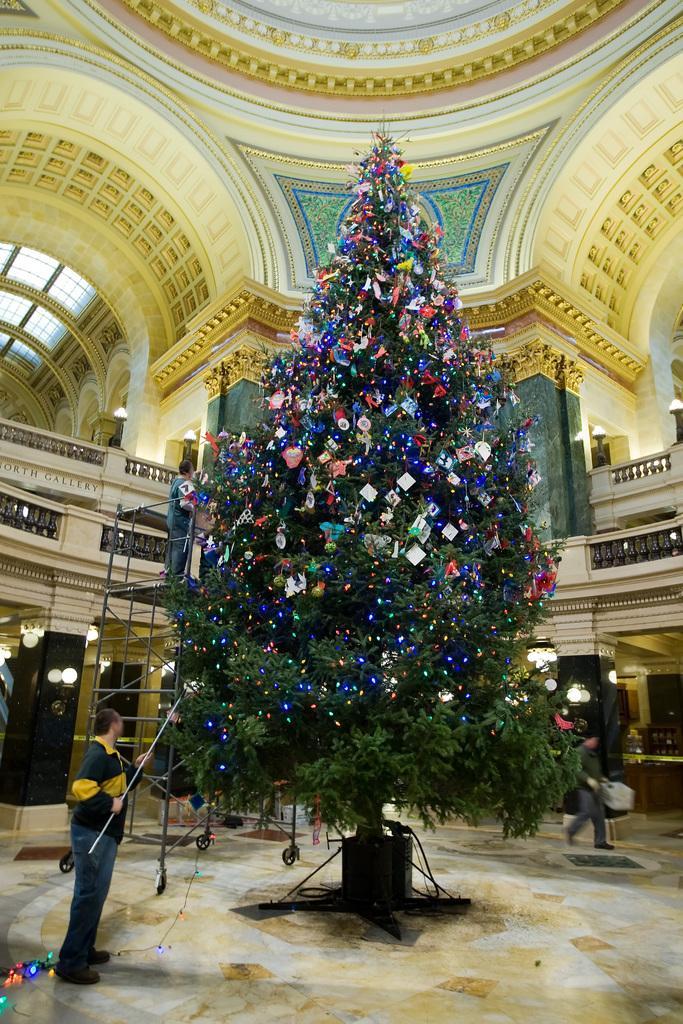Can you describe this image briefly? There is a man standing and holding stick and we can see Christmas tree. Background we can see a person,wall and lights. 